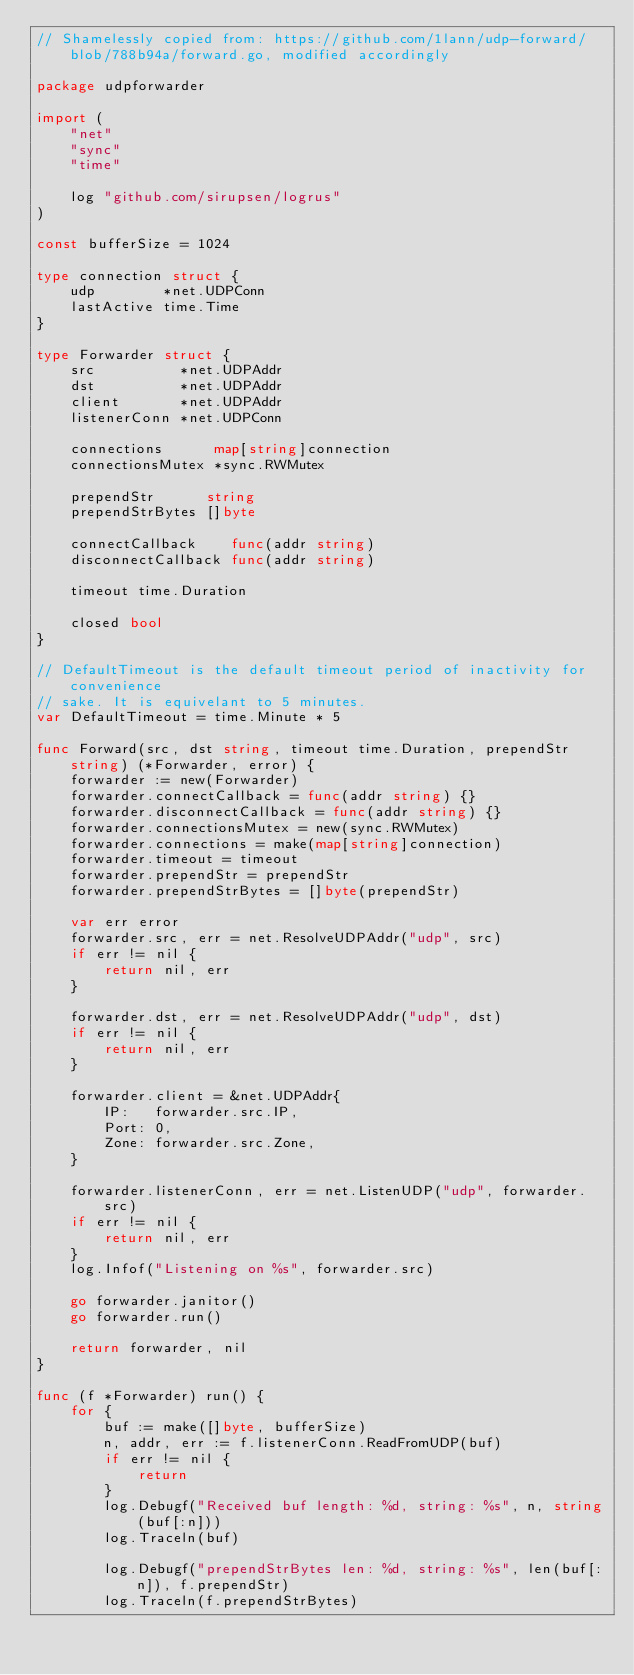<code> <loc_0><loc_0><loc_500><loc_500><_Go_>// Shamelessly copied from: https://github.com/1lann/udp-forward/blob/788b94a/forward.go, modified accordingly

package udpforwarder

import (
	"net"
	"sync"
	"time"

	log "github.com/sirupsen/logrus"
)

const bufferSize = 1024

type connection struct {
	udp        *net.UDPConn
	lastActive time.Time
}

type Forwarder struct {
	src          *net.UDPAddr
	dst          *net.UDPAddr
	client       *net.UDPAddr
	listenerConn *net.UDPConn

	connections      map[string]connection
	connectionsMutex *sync.RWMutex

	prependStr      string
	prependStrBytes []byte

	connectCallback    func(addr string)
	disconnectCallback func(addr string)

	timeout time.Duration

	closed bool
}

// DefaultTimeout is the default timeout period of inactivity for convenience
// sake. It is equivelant to 5 minutes.
var DefaultTimeout = time.Minute * 5

func Forward(src, dst string, timeout time.Duration, prependStr string) (*Forwarder, error) {
	forwarder := new(Forwarder)
	forwarder.connectCallback = func(addr string) {}
	forwarder.disconnectCallback = func(addr string) {}
	forwarder.connectionsMutex = new(sync.RWMutex)
	forwarder.connections = make(map[string]connection)
	forwarder.timeout = timeout
	forwarder.prependStr = prependStr
	forwarder.prependStrBytes = []byte(prependStr)

	var err error
	forwarder.src, err = net.ResolveUDPAddr("udp", src)
	if err != nil {
		return nil, err
	}

	forwarder.dst, err = net.ResolveUDPAddr("udp", dst)
	if err != nil {
		return nil, err
	}

	forwarder.client = &net.UDPAddr{
		IP:   forwarder.src.IP,
		Port: 0,
		Zone: forwarder.src.Zone,
	}

	forwarder.listenerConn, err = net.ListenUDP("udp", forwarder.src)
	if err != nil {
		return nil, err
	}
	log.Infof("Listening on %s", forwarder.src)

	go forwarder.janitor()
	go forwarder.run()

	return forwarder, nil
}

func (f *Forwarder) run() {
	for {
		buf := make([]byte, bufferSize)
		n, addr, err := f.listenerConn.ReadFromUDP(buf)
		if err != nil {
			return
		}
		log.Debugf("Received buf length: %d, string: %s", n, string(buf[:n]))
		log.Traceln(buf)

		log.Debugf("prependStrBytes len: %d, string: %s", len(buf[:n]), f.prependStr)
		log.Traceln(f.prependStrBytes)
</code> 